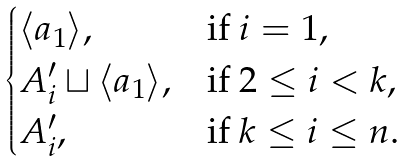Convert formula to latex. <formula><loc_0><loc_0><loc_500><loc_500>\begin{cases} \langle a _ { 1 } \rangle , & \text {if } i = 1 , \\ A ^ { \prime } _ { i } \sqcup \langle a _ { 1 } \rangle , & \text {if } 2 \leq i < k , \\ A ^ { \prime } _ { i } , & \text {if } k \leq i \leq n . \end{cases}</formula> 